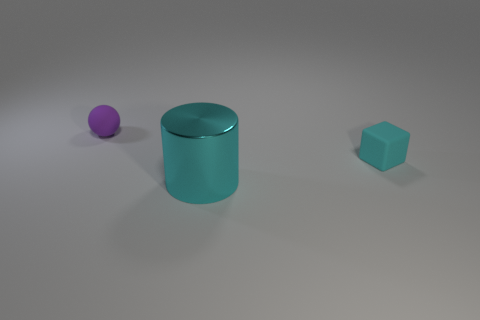Add 2 cyan shiny things. How many objects exist? 5 Subtract all balls. How many objects are left? 2 Add 3 tiny purple matte spheres. How many tiny purple matte spheres are left? 4 Add 3 large green cylinders. How many large green cylinders exist? 3 Subtract 1 cyan cubes. How many objects are left? 2 Subtract all small blue things. Subtract all large objects. How many objects are left? 2 